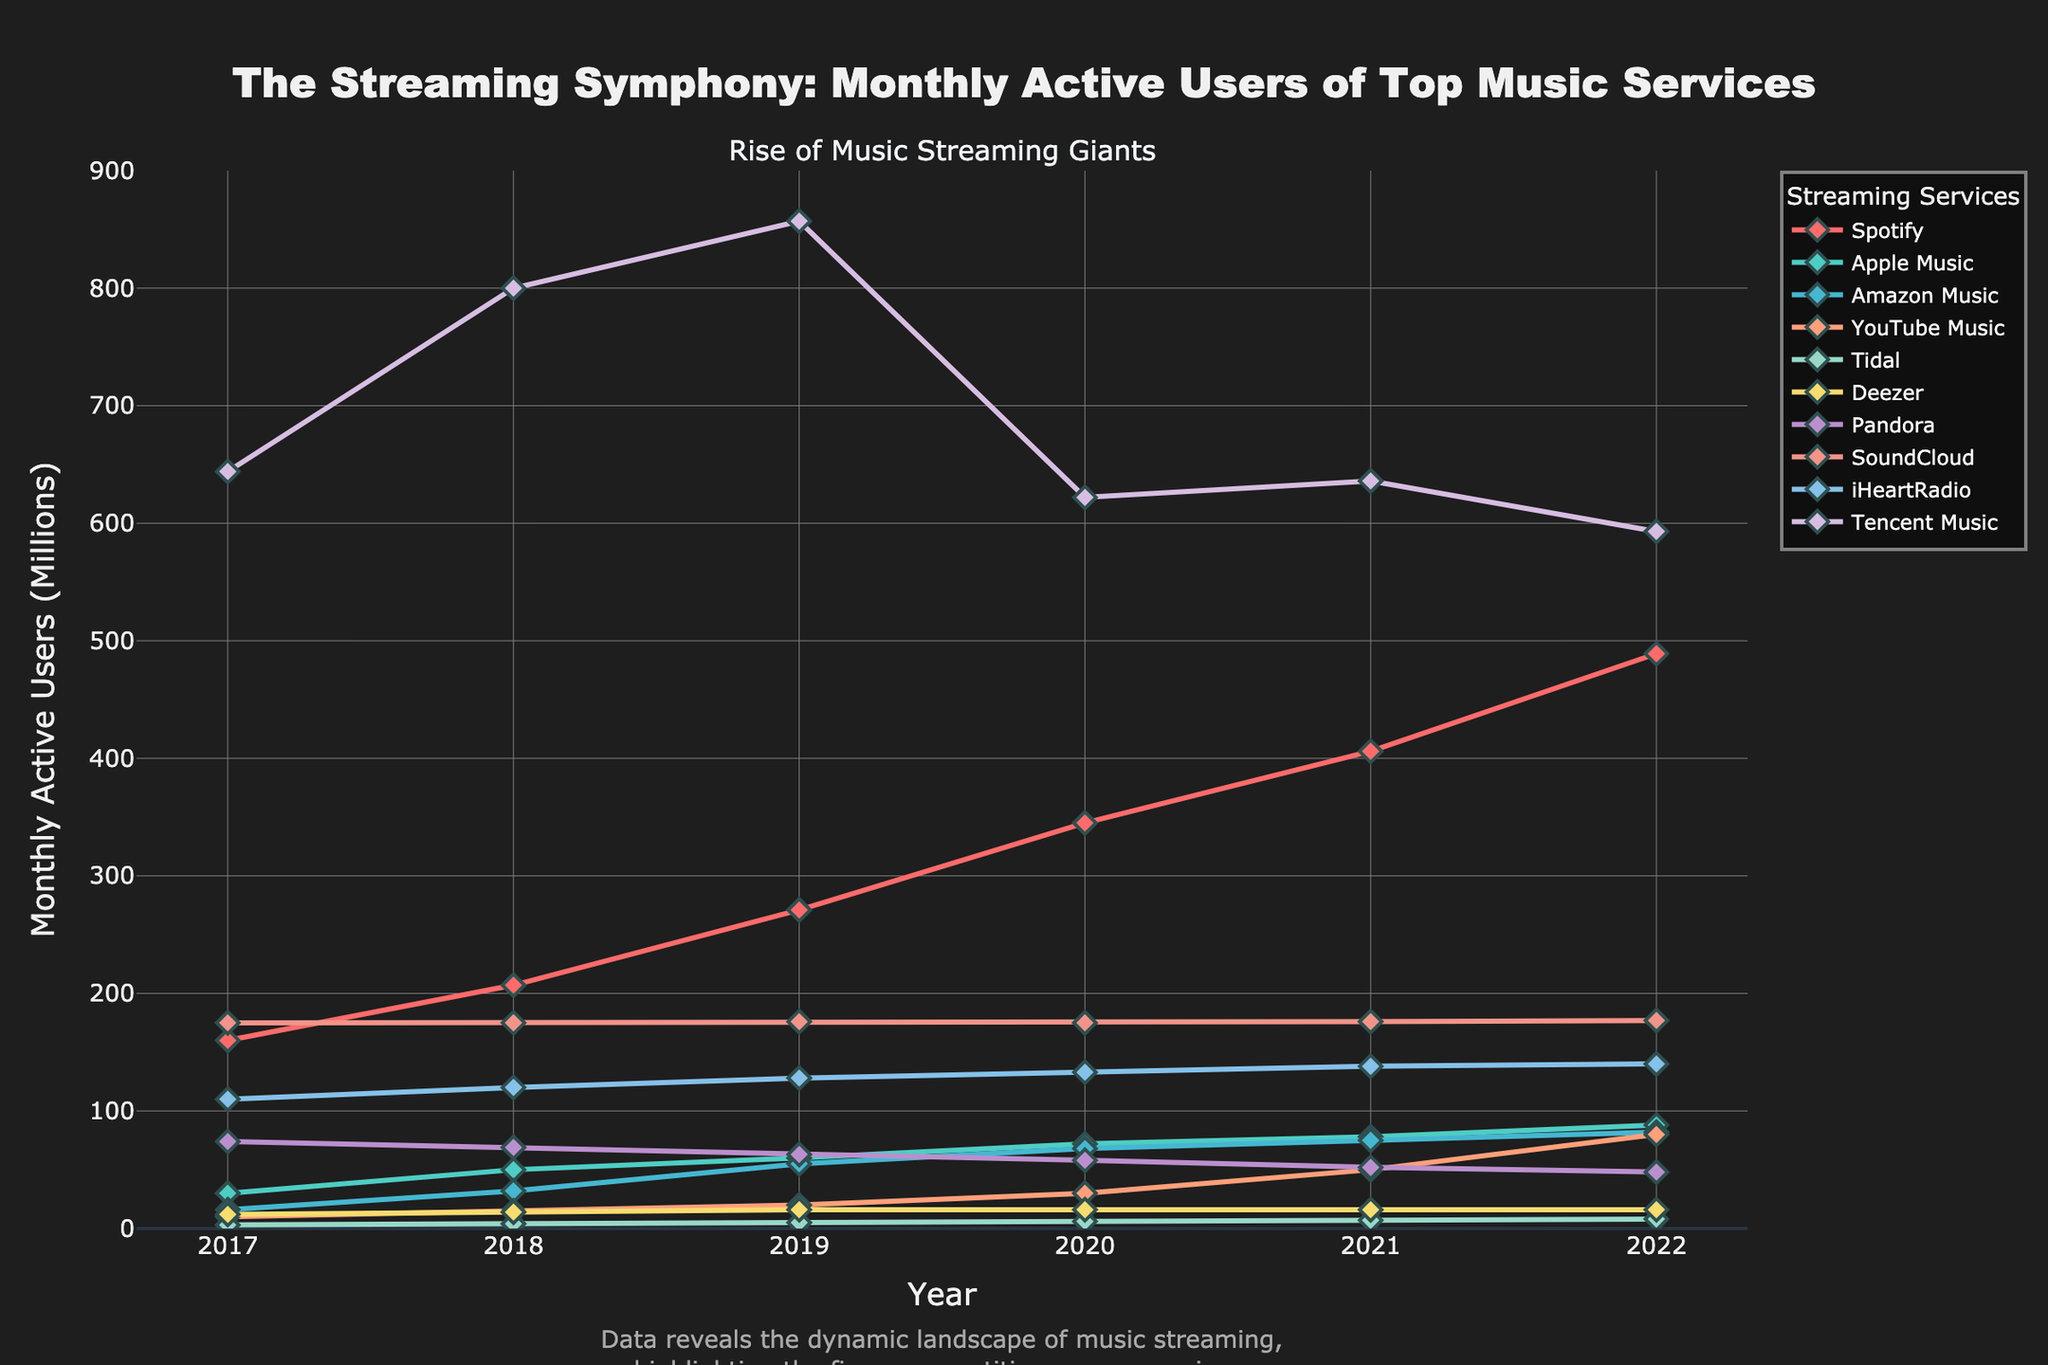Which streaming service had the highest number of monthly active users in 2022? The streaming service with the highest monthly active users in 2022 can be identified by looking at the peaks of the lines on the far right side of the chart. Tencent Music has the highest peak in 2022.
Answer: Tencent Music What is the total sum of active users for Spotify from 2017 to 2022? To determine the sum, add the monthly active users for Spotify across all years: (160 + 207 + 271 + 345 + 406 + 489) = 1878.
Answer: 1878 Which service showed the least growth in monthly active users between 2017 and 2022? To find the service with the least growth, calculate the difference between the 2022 and 2017 values for each service. Deezer’s users remained constant at 16 million from 2019 to 2022, showing minimal growth compared to others.
Answer: Deezer Compare the monthly active users of Apple Music and Amazon Music in 2022. Which one had more users? By examining the right end of the chart, compare the points for Apple Music and Amazon Music in 2022. Apple Music had 88 million monthly active users, while Amazon Music had 82 million.
Answer: Apple Music What is the average number of monthly active users for Tidal from 2017 to 2022? Calculate the average by summing the values for Tidal from 2017 to 2022 and then dividing by the count of the years: (3 + 4 + 5 + 6 + 7 + 8) / 6 = 33 / 6 ≈ 5.5.
Answer: 5.5 Which streaming service experienced a drop in monthly active users from 2019 to 2020? Spotting the lines with a downward trend between 2019 and 2020, Tencent Music shows a clear drop, from 857 million to 622 million users.
Answer: Tencent Music How did YouTube Music's monthly active users change from 2017 to 2022? Analyze the trend for YouTube Music from 2017 to 2022. It shows a steady increase from 10 million users in 2017 to 80 million users in 2022.
Answer: Increased Between Pandora and SoundCloud, which one had more monthly active users in 2018? Locate the 2018 points for both Pandora and SoundCloud on the chart. Pandora had 69 million, and SoundCloud had 175 million monthly active users in 2018.
Answer: SoundCloud Which service’s line is visually represented with the light blue color? Identify the line colored light blue in the chart. It is labeled "Amazon Music."
Answer: Amazon Music What is the difference in monthly active users for iHeartRadio between 2019 and 2022? Calculate the difference by subtracting the value in 2019 from the value in 2022: 140 - 128 = 12 million.
Answer: 12 million 